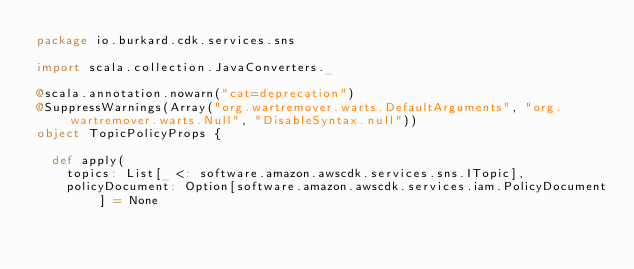Convert code to text. <code><loc_0><loc_0><loc_500><loc_500><_Scala_>package io.burkard.cdk.services.sns

import scala.collection.JavaConverters._

@scala.annotation.nowarn("cat=deprecation")
@SuppressWarnings(Array("org.wartremover.warts.DefaultArguments", "org.wartremover.warts.Null", "DisableSyntax.null"))
object TopicPolicyProps {

  def apply(
    topics: List[_ <: software.amazon.awscdk.services.sns.ITopic],
    policyDocument: Option[software.amazon.awscdk.services.iam.PolicyDocument] = None</code> 